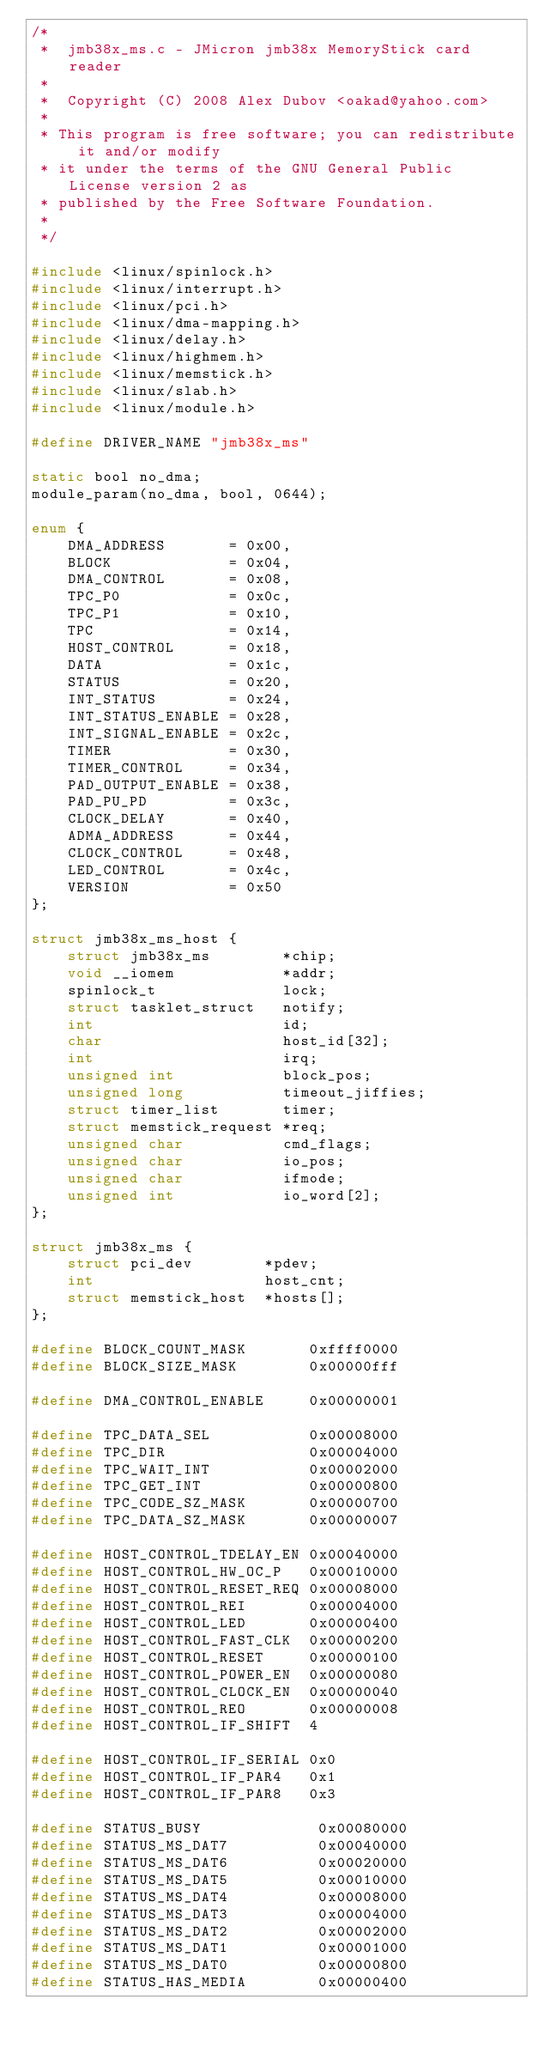Convert code to text. <code><loc_0><loc_0><loc_500><loc_500><_C_>/*
 *  jmb38x_ms.c - JMicron jmb38x MemoryStick card reader
 *
 *  Copyright (C) 2008 Alex Dubov <oakad@yahoo.com>
 *
 * This program is free software; you can redistribute it and/or modify
 * it under the terms of the GNU General Public License version 2 as
 * published by the Free Software Foundation.
 *
 */

#include <linux/spinlock.h>
#include <linux/interrupt.h>
#include <linux/pci.h>
#include <linux/dma-mapping.h>
#include <linux/delay.h>
#include <linux/highmem.h>
#include <linux/memstick.h>
#include <linux/slab.h>
#include <linux/module.h>

#define DRIVER_NAME "jmb38x_ms"

static bool no_dma;
module_param(no_dma, bool, 0644);

enum {
	DMA_ADDRESS       = 0x00,
	BLOCK             = 0x04,
	DMA_CONTROL       = 0x08,
	TPC_P0            = 0x0c,
	TPC_P1            = 0x10,
	TPC               = 0x14,
	HOST_CONTROL      = 0x18,
	DATA              = 0x1c,
	STATUS            = 0x20,
	INT_STATUS        = 0x24,
	INT_STATUS_ENABLE = 0x28,
	INT_SIGNAL_ENABLE = 0x2c,
	TIMER             = 0x30,
	TIMER_CONTROL     = 0x34,
	PAD_OUTPUT_ENABLE = 0x38,
	PAD_PU_PD         = 0x3c,
	CLOCK_DELAY       = 0x40,
	ADMA_ADDRESS      = 0x44,
	CLOCK_CONTROL     = 0x48,
	LED_CONTROL       = 0x4c,
	VERSION           = 0x50
};

struct jmb38x_ms_host {
	struct jmb38x_ms        *chip;
	void __iomem            *addr;
	spinlock_t              lock;
	struct tasklet_struct   notify;
	int                     id;
	char                    host_id[32];
	int                     irq;
	unsigned int            block_pos;
	unsigned long           timeout_jiffies;
	struct timer_list       timer;
	struct memstick_request *req;
	unsigned char           cmd_flags;
	unsigned char           io_pos;
	unsigned char           ifmode;
	unsigned int            io_word[2];
};

struct jmb38x_ms {
	struct pci_dev        *pdev;
	int                   host_cnt;
	struct memstick_host  *hosts[];
};

#define BLOCK_COUNT_MASK       0xffff0000
#define BLOCK_SIZE_MASK        0x00000fff

#define DMA_CONTROL_ENABLE     0x00000001

#define TPC_DATA_SEL           0x00008000
#define TPC_DIR                0x00004000
#define TPC_WAIT_INT           0x00002000
#define TPC_GET_INT            0x00000800
#define TPC_CODE_SZ_MASK       0x00000700
#define TPC_DATA_SZ_MASK       0x00000007

#define HOST_CONTROL_TDELAY_EN 0x00040000
#define HOST_CONTROL_HW_OC_P   0x00010000
#define HOST_CONTROL_RESET_REQ 0x00008000
#define HOST_CONTROL_REI       0x00004000
#define HOST_CONTROL_LED       0x00000400
#define HOST_CONTROL_FAST_CLK  0x00000200
#define HOST_CONTROL_RESET     0x00000100
#define HOST_CONTROL_POWER_EN  0x00000080
#define HOST_CONTROL_CLOCK_EN  0x00000040
#define HOST_CONTROL_REO       0x00000008
#define HOST_CONTROL_IF_SHIFT  4

#define HOST_CONTROL_IF_SERIAL 0x0
#define HOST_CONTROL_IF_PAR4   0x1
#define HOST_CONTROL_IF_PAR8   0x3

#define STATUS_BUSY             0x00080000
#define STATUS_MS_DAT7          0x00040000
#define STATUS_MS_DAT6          0x00020000
#define STATUS_MS_DAT5          0x00010000
#define STATUS_MS_DAT4          0x00008000
#define STATUS_MS_DAT3          0x00004000
#define STATUS_MS_DAT2          0x00002000
#define STATUS_MS_DAT1          0x00001000
#define STATUS_MS_DAT0          0x00000800
#define STATUS_HAS_MEDIA        0x00000400</code> 